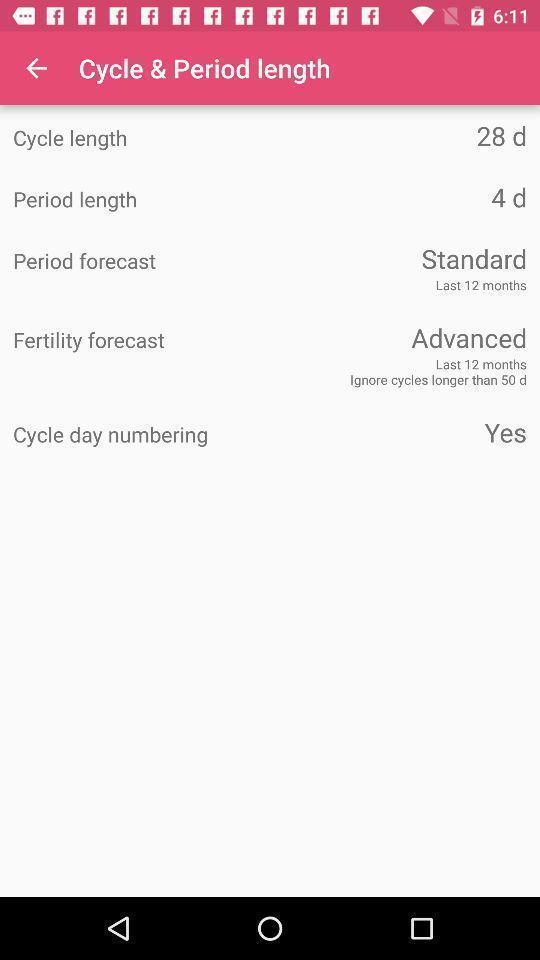Tell me about the visual elements in this screen capture. Screen shows details about cycle period length. 